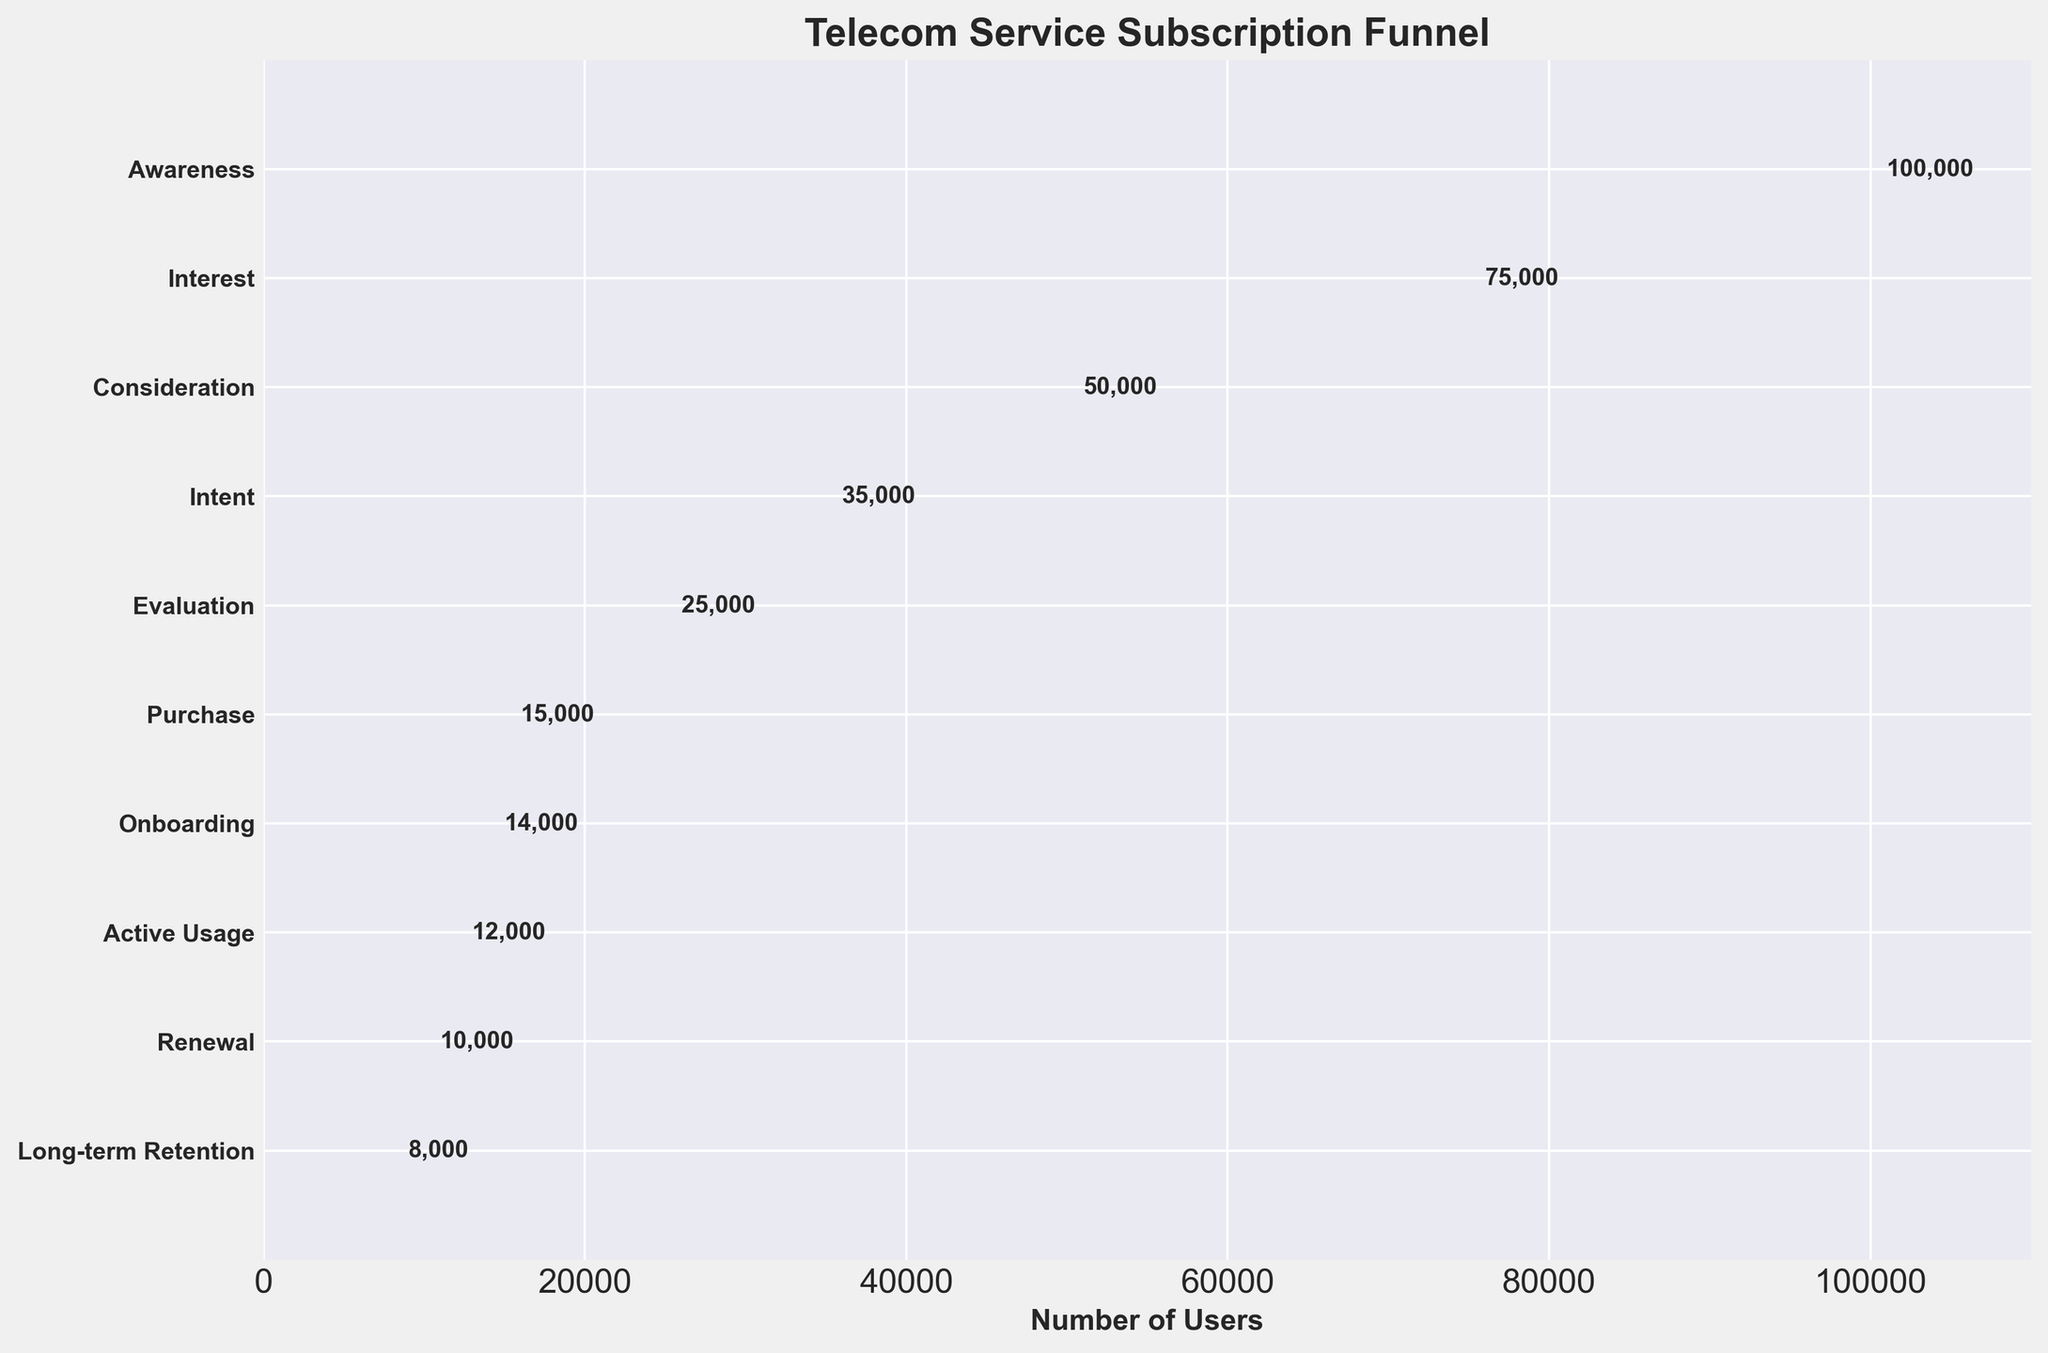What's the title of the funnel chart? The title is the text prominently displayed at the top of the chart. It provides a clear indication of what the chart represents.
Answer: Telecom Service Subscription Funnel How many stages are there in the funnel? Count the number of distinct stages labeled on the Y-axis of the chart.
Answer: 10 What is the number of users at the "Active Usage" stage? Look at the corresponding bar in the funnel chart and read the user count displayed next to the "Active Usage" stage.
Answer: 12,000 How many users drop off between the "Purchase" and "Onboarding" stages? Subtract the number of users in the "Onboarding" stage from the number of users in the "Purchase" stage (15,000 - 14,000).
Answer: 1,000 Which stage has the highest user drop-off between consecutive stages? Identify the consecutive stages with the largest difference in user counts by comparing the user drop-offs between each pair of adjacent stages.
Answer: Purchase to Onboarding What proportion of users who were aware of the service made it to the "Purchase" stage? Divide the number of users at the "Purchase" stage by the users at the "Awareness" stage and multiply by 100 to get a percentage (15,000 / 100,000 * 100).
Answer: 15% How many more users are in the "Interest" stage compared to the "Evaluation" stage? Subtract the number of users in the "Evaluation" stage from the number of users in the "Interest" stage (75,000 - 25,000).
Answer: 50,000 What is the change in the number of users from the "Intent" stage to the "Renewal" stage? Subtract the number of users in the "Renewal" stage from the number of users in the "Intent" stage (35,000 - 10,000).
Answer: 25,000 What percentage of users in the "Onboarding" stage continue to "Long-term Retention"? Divide the number of users at the "Long-term Retention" stage by the users at the "Onboarding" stage and multiply by 100 to get a percentage (8,000 / 14,000 * 100).
Answer: 57.14% Between which two consecutive stages is the user number closest to being the same? Look for pairs of consecutive stages with the smallest difference in user counts by comparing differences across all pairs of adjacent stages.
Answer: Onboarding to Active Usage 